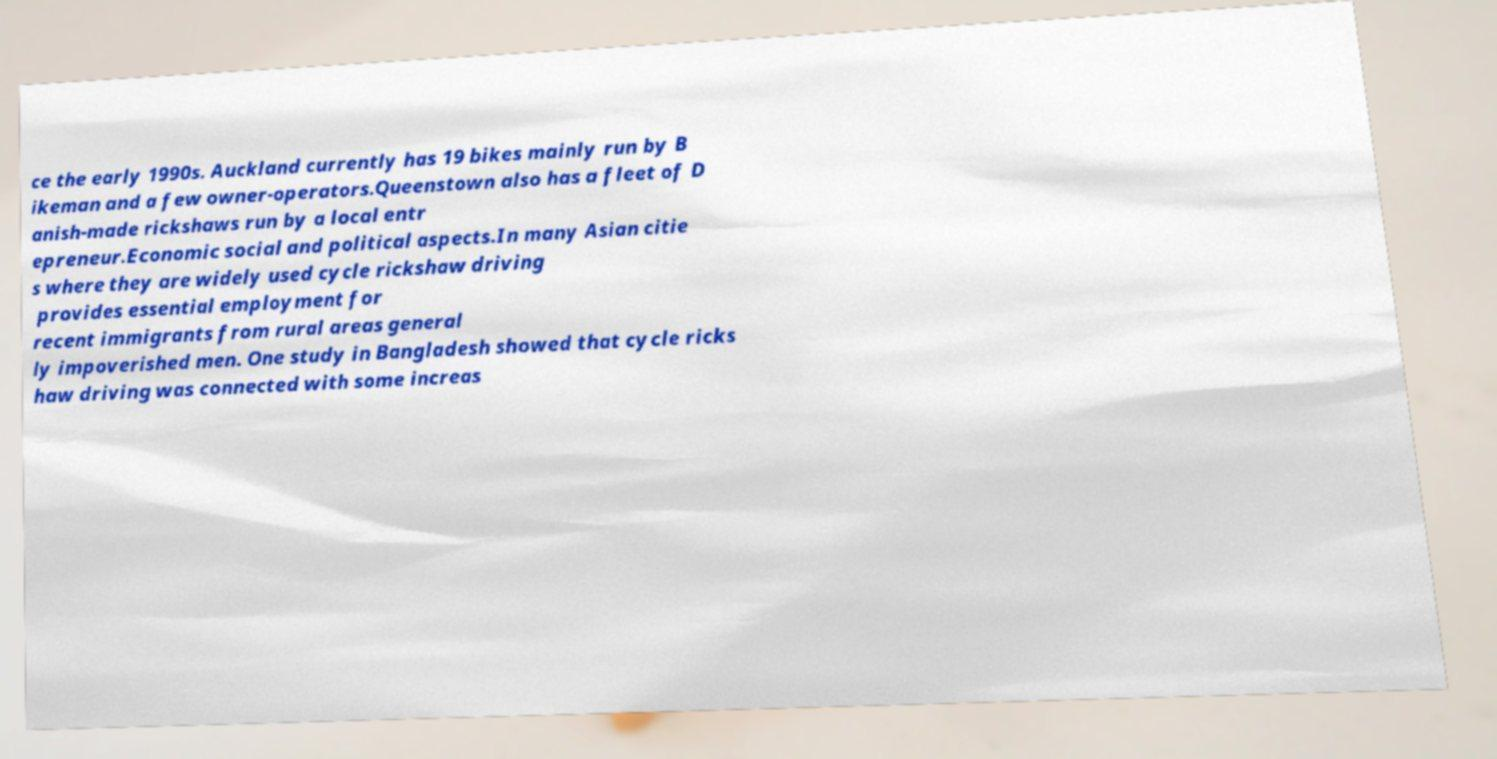Could you extract and type out the text from this image? ce the early 1990s. Auckland currently has 19 bikes mainly run by B ikeman and a few owner-operators.Queenstown also has a fleet of D anish-made rickshaws run by a local entr epreneur.Economic social and political aspects.In many Asian citie s where they are widely used cycle rickshaw driving provides essential employment for recent immigrants from rural areas general ly impoverished men. One study in Bangladesh showed that cycle ricks haw driving was connected with some increas 